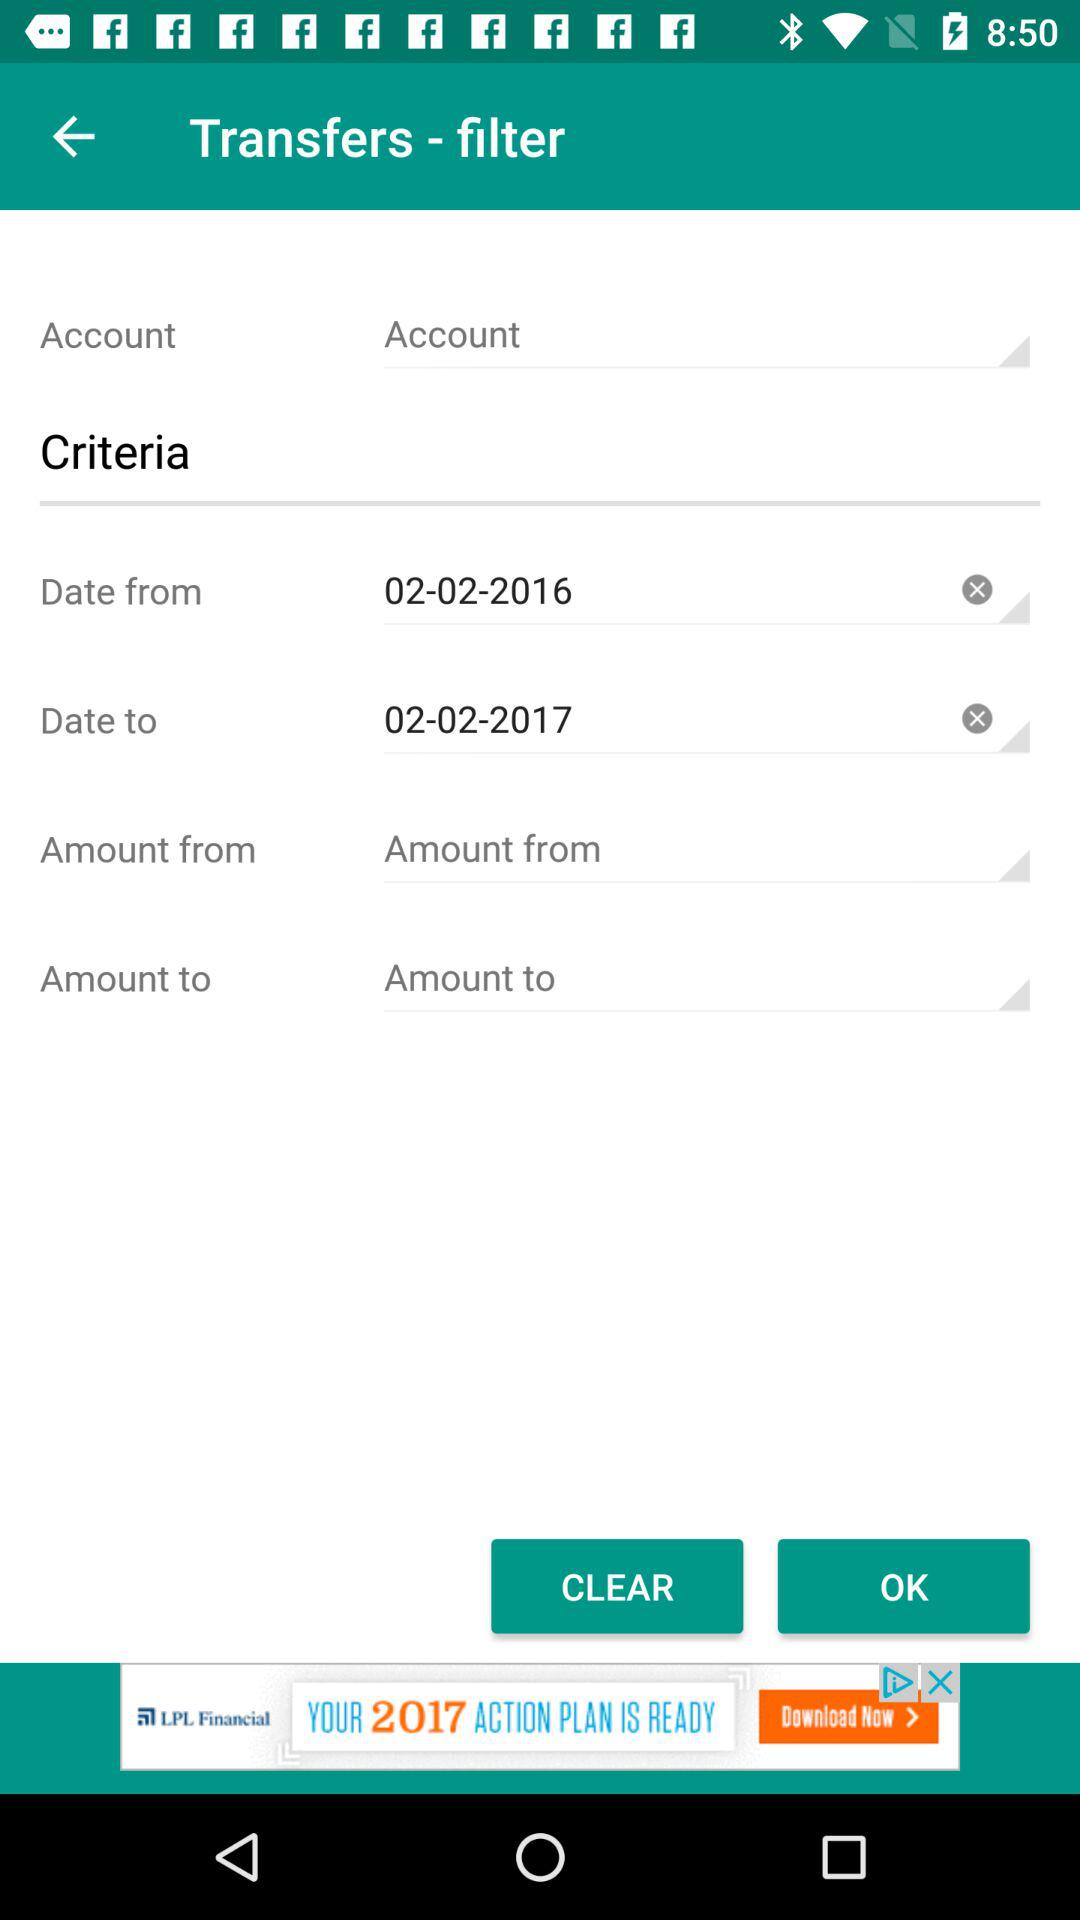What were the dates picked for the duration? The dates were 02-02-2017 to 02-02-2017. 